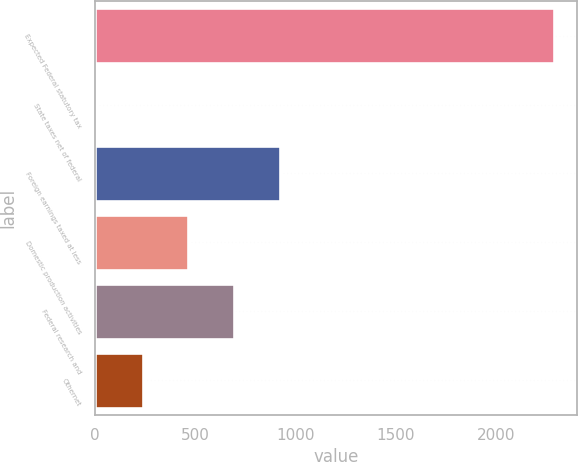Convert chart to OTSL. <chart><loc_0><loc_0><loc_500><loc_500><bar_chart><fcel>Expected Federal statutory tax<fcel>State taxes net of federal<fcel>Foreign earnings taxed at less<fcel>Domestic production activities<fcel>Federal research and<fcel>Othernet<nl><fcel>2293<fcel>8<fcel>922<fcel>465<fcel>693.5<fcel>236.5<nl></chart> 